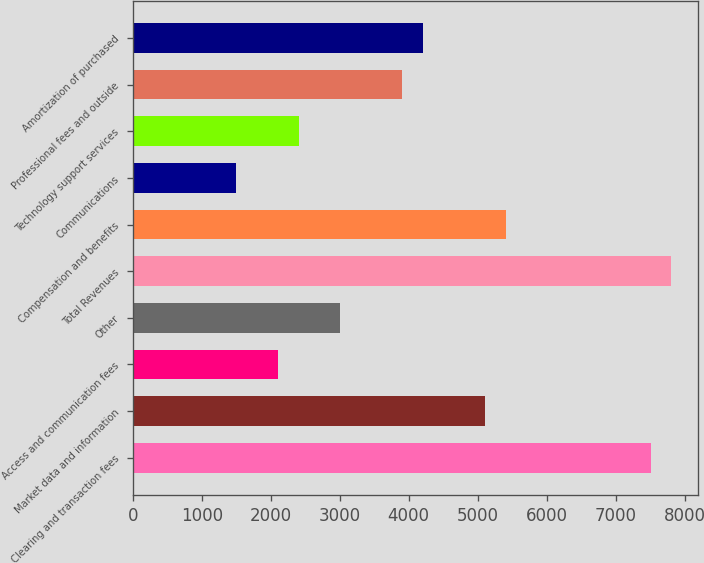Convert chart. <chart><loc_0><loc_0><loc_500><loc_500><bar_chart><fcel>Clearing and transaction fees<fcel>Market data and information<fcel>Access and communication fees<fcel>Other<fcel>Total Revenues<fcel>Compensation and benefits<fcel>Communications<fcel>Technology support services<fcel>Professional fees and outside<fcel>Amortization of purchased<nl><fcel>7508.2<fcel>5105.8<fcel>2102.8<fcel>3003.7<fcel>7808.5<fcel>5406.1<fcel>1502.2<fcel>2403.1<fcel>3904.6<fcel>4204.9<nl></chart> 